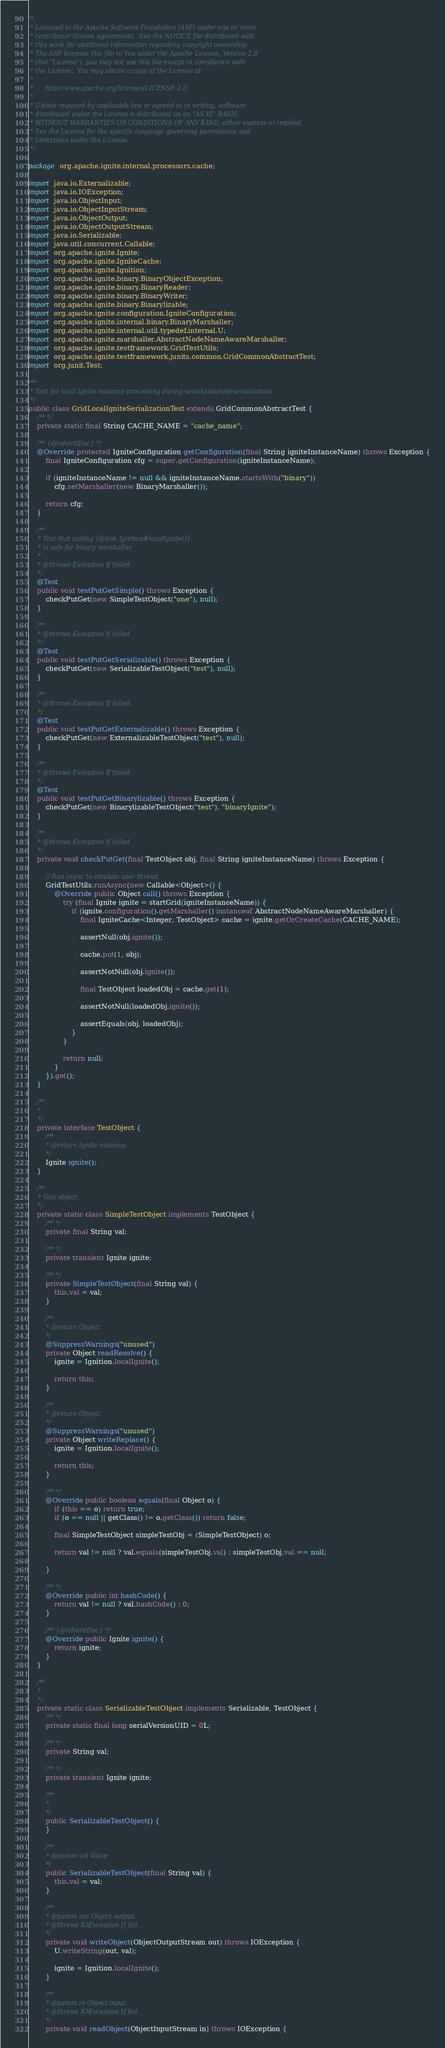<code> <loc_0><loc_0><loc_500><loc_500><_Java_>/*
 * Licensed to the Apache Software Foundation (ASF) under one or more
 * contributor license agreements.  See the NOTICE file distributed with
 * this work for additional information regarding copyright ownership.
 * The ASF licenses this file to You under the Apache License, Version 2.0
 * (the "License"); you may not use this file except in compliance with
 * the License.  You may obtain a copy of the License at
 *
 *      http://www.apache.org/licenses/LICENSE-2.0
 *
 * Unless required by applicable law or agreed to in writing, software
 * distributed under the License is distributed on an "AS IS" BASIS,
 * WITHOUT WARRANTIES OR CONDITIONS OF ANY KIND, either express or implied.
 * See the License for the specific language governing permissions and
 * limitations under the License.
 */

package org.apache.ignite.internal.processors.cache;

import java.io.Externalizable;
import java.io.IOException;
import java.io.ObjectInput;
import java.io.ObjectInputStream;
import java.io.ObjectOutput;
import java.io.ObjectOutputStream;
import java.io.Serializable;
import java.util.concurrent.Callable;
import org.apache.ignite.Ignite;
import org.apache.ignite.IgniteCache;
import org.apache.ignite.Ignition;
import org.apache.ignite.binary.BinaryObjectException;
import org.apache.ignite.binary.BinaryReader;
import org.apache.ignite.binary.BinaryWriter;
import org.apache.ignite.binary.Binarylizable;
import org.apache.ignite.configuration.IgniteConfiguration;
import org.apache.ignite.internal.binary.BinaryMarshaller;
import org.apache.ignite.internal.util.typedef.internal.U;
import org.apache.ignite.marshaller.AbstractNodeNameAwareMarshaller;
import org.apache.ignite.testframework.GridTestUtils;
import org.apache.ignite.testframework.junits.common.GridCommonAbstractTest;
import org.junit.Test;

/**
 * Test for local Ignite instance processing during serialization/deserialization.
 */
public class GridLocalIgniteSerializationTest extends GridCommonAbstractTest {
    /** */
    private static final String CACHE_NAME = "cache_name";

    /** {@inheritDoc} */
    @Override protected IgniteConfiguration getConfiguration(final String igniteInstanceName) throws Exception {
        final IgniteConfiguration cfg = super.getConfiguration(igniteInstanceName);

        if (igniteInstanceName != null && igniteInstanceName.startsWith("binary"))
            cfg.setMarshaller(new BinaryMarshaller());

        return cfg;
    }

    /**
     * Test that calling {@link Ignition#localIgnite()}
     * is safe for binary marshaller.
     *
     * @throws Exception If failed.
     */
    @Test
    public void testPutGetSimple() throws Exception {
        checkPutGet(new SimpleTestObject("one"), null);
    }

    /**
     * @throws Exception If failed.
     */
    @Test
    public void testPutGetSerializable() throws Exception {
        checkPutGet(new SerializableTestObject("test"), null);
    }

    /**
     * @throws Exception If failed.
     */
    @Test
    public void testPutGetExternalizable() throws Exception {
        checkPutGet(new ExternalizableTestObject("test"), null);
    }

    /**
     * @throws Exception If failed.
     */
    @Test
    public void testPutGetBinarylizable() throws Exception {
        checkPutGet(new BinarylizableTestObject("test"), "binaryIgnite");
    }

    /**
     * @throws Exception If failed.
     */
    private void checkPutGet(final TestObject obj, final String igniteInstanceName) throws Exception {

        // Run async to emulate user thread.
        GridTestUtils.runAsync(new Callable<Object>() {
            @Override public Object call() throws Exception {
                try (final Ignite ignite = startGrid(igniteInstanceName)) {
                    if (ignite.configuration().getMarshaller() instanceof AbstractNodeNameAwareMarshaller) {
                        final IgniteCache<Integer, TestObject> cache = ignite.getOrCreateCache(CACHE_NAME);

                        assertNull(obj.ignite());

                        cache.put(1, obj);

                        assertNotNull(obj.ignite());

                        final TestObject loadedObj = cache.get(1);

                        assertNotNull(loadedObj.ignite());

                        assertEquals(obj, loadedObj);
                    }
                }

                return null;
            }
        }).get();
    }

    /**
     *
     */
    private interface TestObject {
        /**
         * @return Ignite instance.
         */
        Ignite ignite();
    }

    /**
     * Test object.
     */
    private static class SimpleTestObject implements TestObject {
        /** */
        private final String val;

        /** */
        private transient Ignite ignite;

        /** */
        private SimpleTestObject(final String val) {
            this.val = val;
        }

        /**
         * @return Object.
         */
        @SuppressWarnings("unused")
        private Object readResolve() {
            ignite = Ignition.localIgnite();

            return this;
        }

        /**
         * @return Object.
         */
        @SuppressWarnings("unused")
        private Object writeReplace() {
            ignite = Ignition.localIgnite();

            return this;
        }

        /** */
        @Override public boolean equals(final Object o) {
            if (this == o) return true;
            if (o == null || getClass() != o.getClass()) return false;

            final SimpleTestObject simpleTestObj = (SimpleTestObject) o;

            return val != null ? val.equals(simpleTestObj.val) : simpleTestObj.val == null;

        }

        /** */
        @Override public int hashCode() {
            return val != null ? val.hashCode() : 0;
        }

        /** {@inheritDoc} */
        @Override public Ignite ignite() {
            return ignite;
        }
    }

    /**
     *
     */
    private static class SerializableTestObject implements Serializable, TestObject {
        /** */
        private static final long serialVersionUID = 0L;

        /** */
        private String val;

        /** */
        private transient Ignite ignite;

        /**
         *
         */
        public SerializableTestObject() {
        }

        /**
         * @param val Value
         */
        public SerializableTestObject(final String val) {
            this.val = val;
        }

        /**
         * @param out Object output.
         * @throws IOException If fail.
         */
        private void writeObject(ObjectOutputStream out) throws IOException {
            U.writeString(out, val);

            ignite = Ignition.localIgnite();
        }

        /**
         * @param in Object input.
         * @throws IOException If fail.
         */
        private void readObject(ObjectInputStream in) throws IOException {</code> 